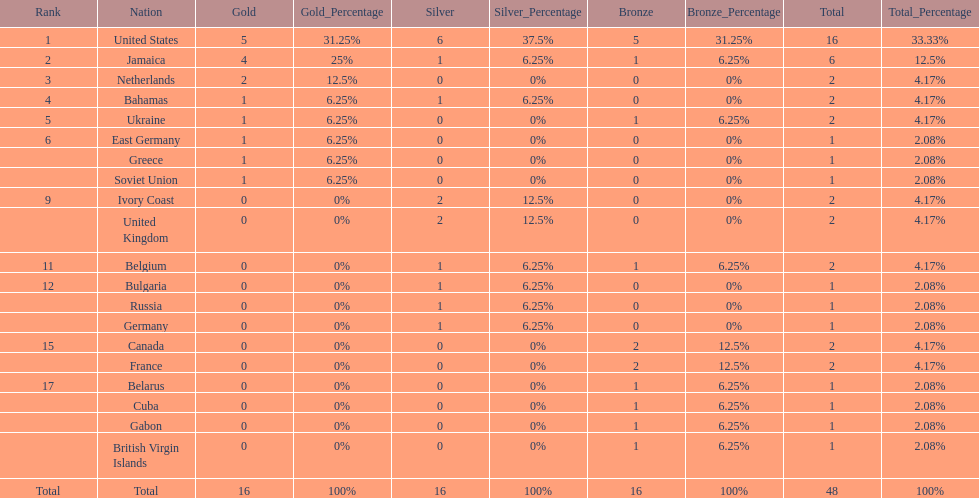What number of nations received 1 medal? 10. 